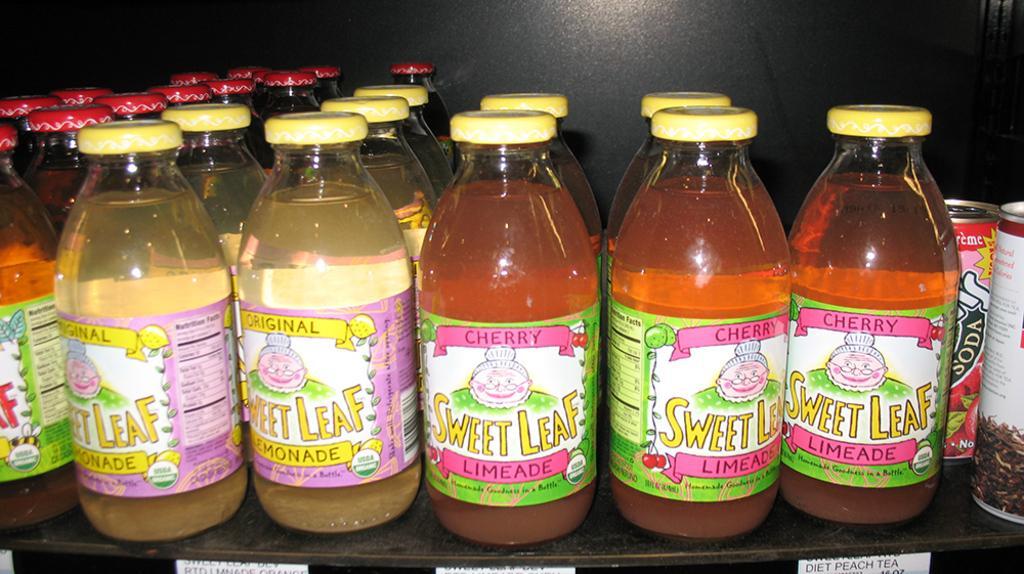Describe this image in one or two sentences. In this image I see a number of bottles and 2 cans. 